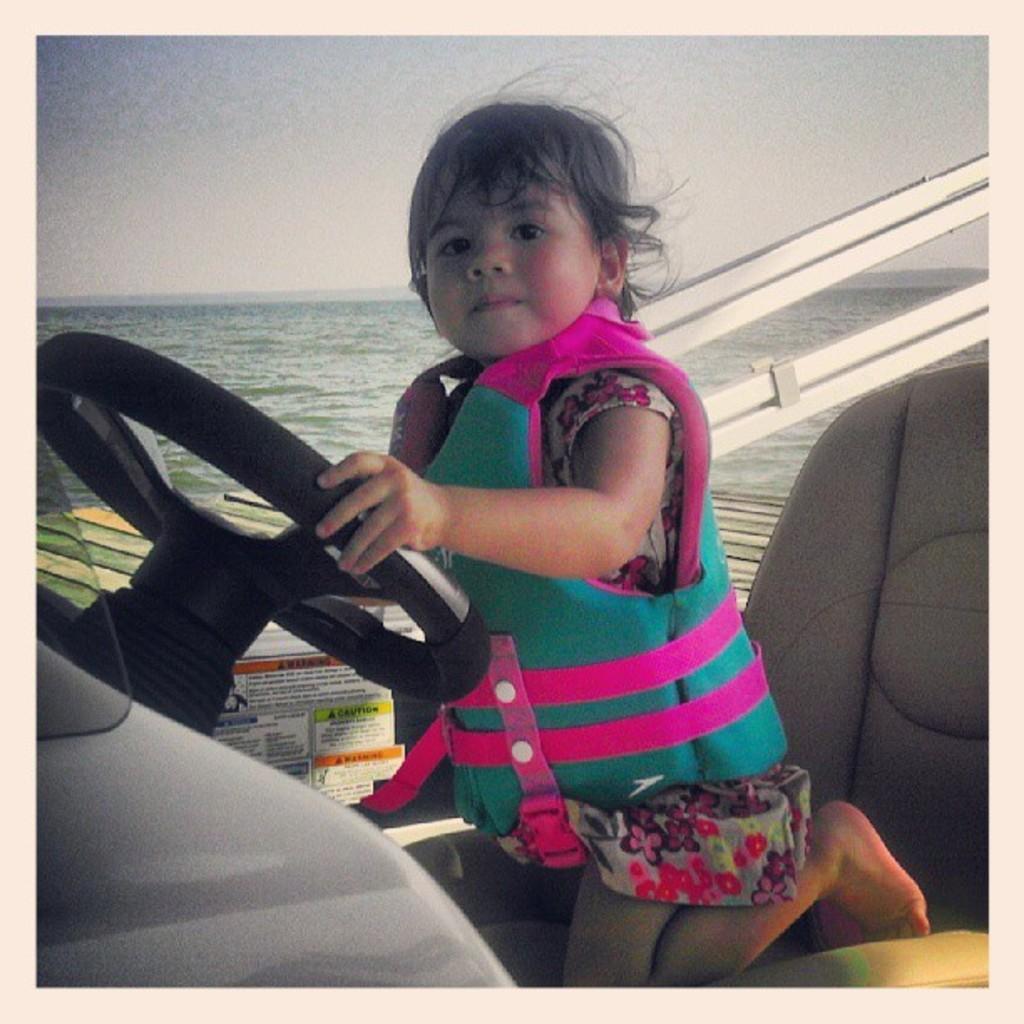Please provide a concise description of this image. In the center of the image we can see girl sitting on the chair and holding steering. In the background we can see water and sky. 